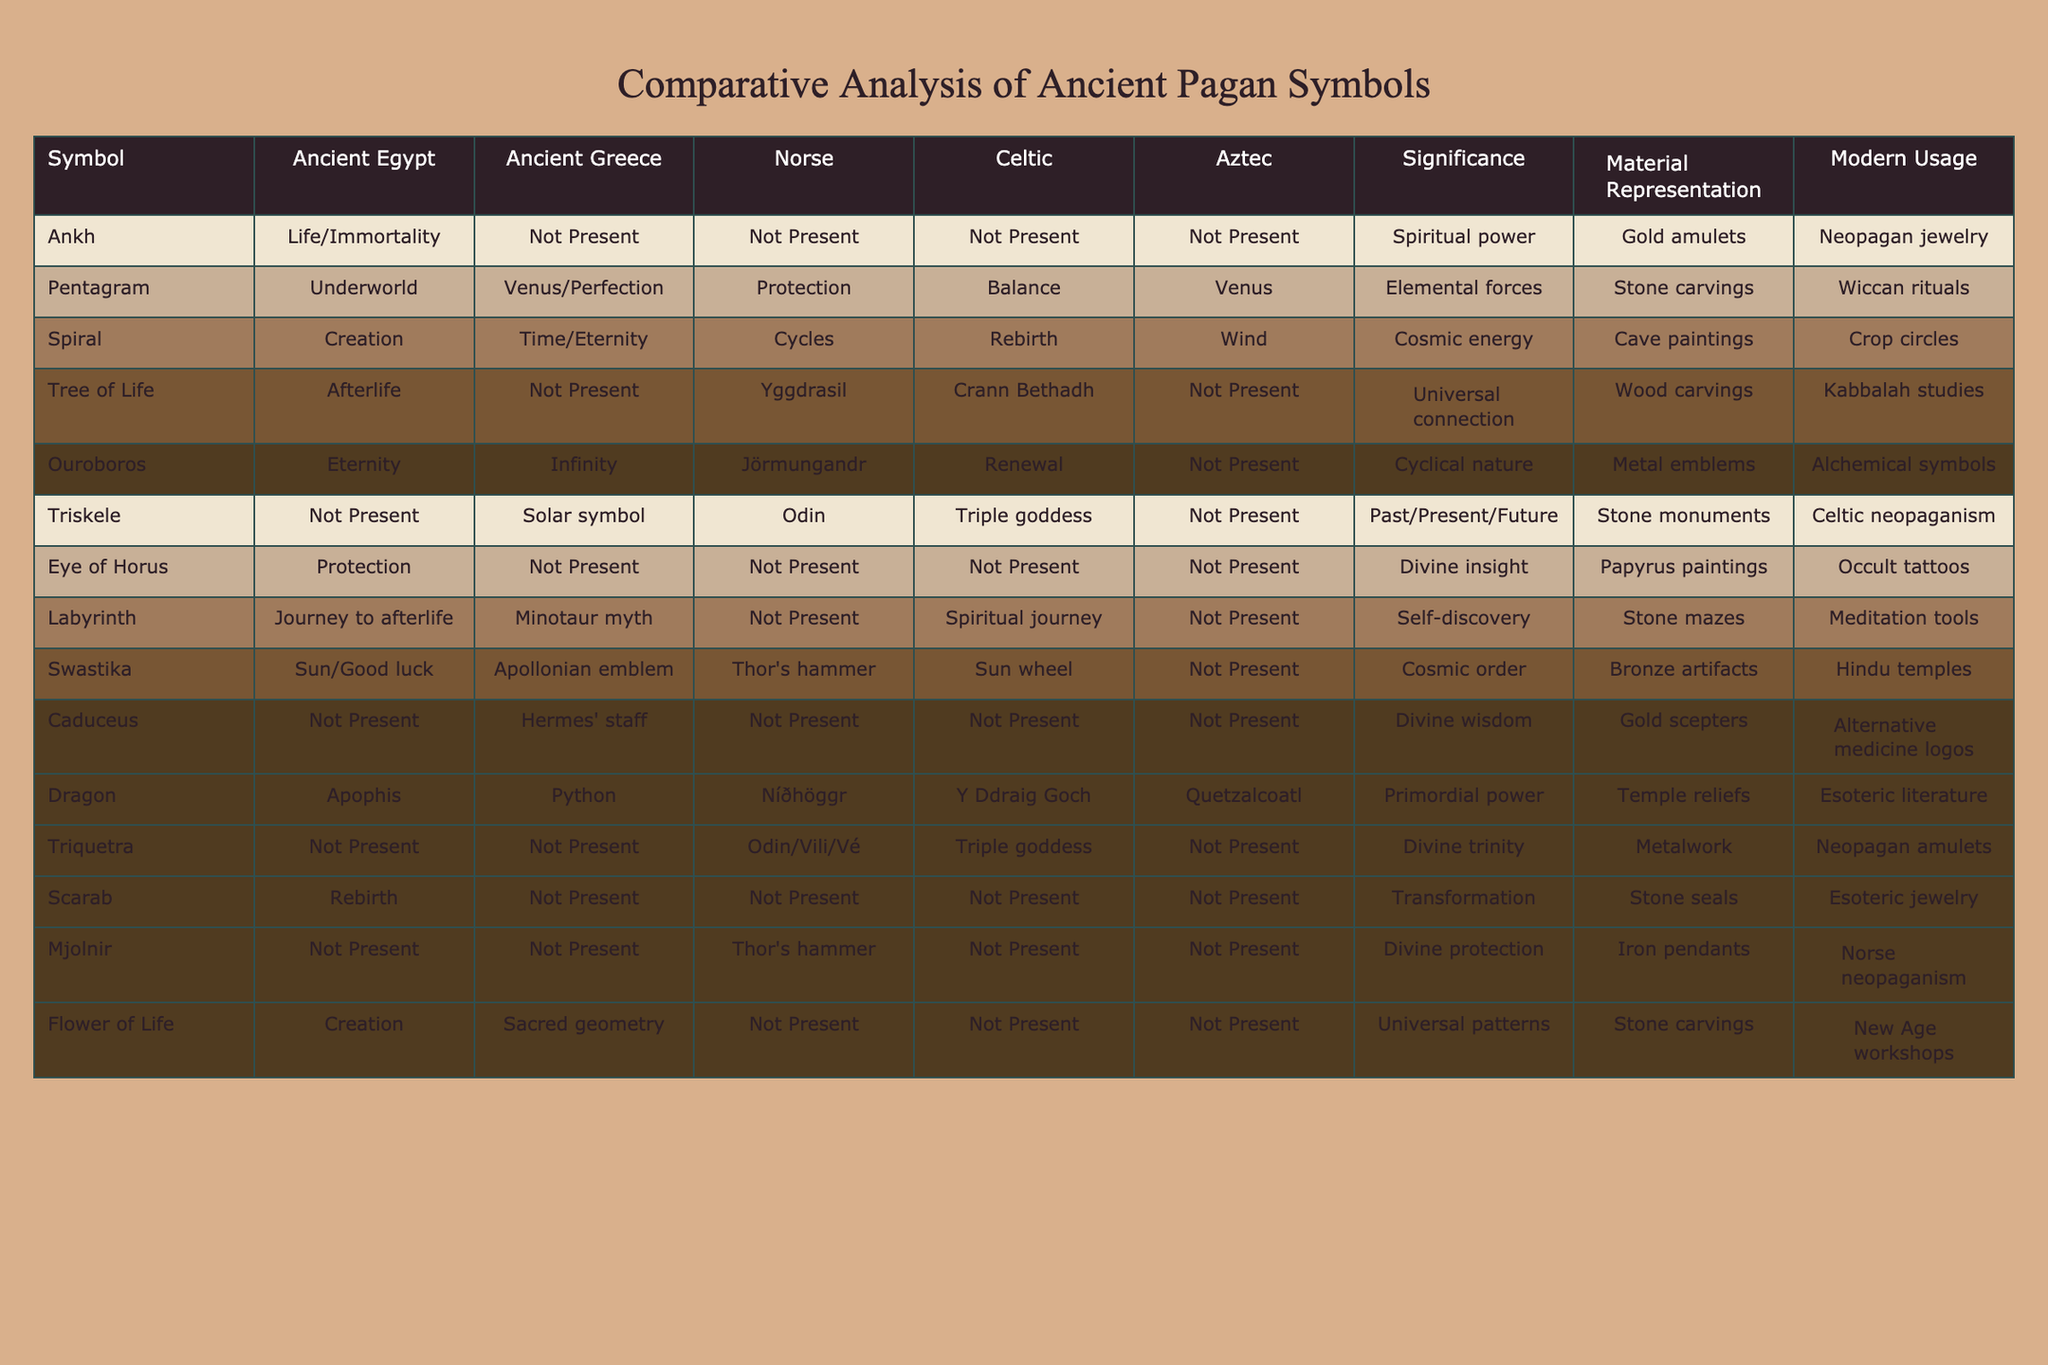What is the significance of the Ankh symbol in Ancient Egypt? According to the table, the Ankh symbol represents life and immortality in Ancient Egypt.
Answer: Life/Immortality Which symbols are associated with the concept of protection? The symbols related to protection in the table are the Pentagram in Ancient Greece and the Eye of Horus in Ancient Egypt.
Answer: Pentagram, Eye of Horus How many cultures recognize the Ouroboros symbol, and what does it signify? The Ouroboros symbol is recognized in Ancient Egypt and Norse cultures, signifying eternity in Egypt and cyclical nature in Norse mythology.
Answer: 2 cultures; Eternity, Cyclical nature Which symbol has a representation of divine wisdom? The Caduceus is the symbol representing divine wisdom, specifically associated with Hermes' staff in Ancient Greece.
Answer: Caduceus Does the Spiral symbol appear in all cultures listed? No, the Spiral symbol does not appear in Ancient Greece and Aztec cultures according to the table.
Answer: No What is the common theme among the symbols that signify creation? The Spiral and Flower of Life symbols represent creation, with Spiral associated with creation in various cultures and Flower of Life recognized in Ancient Greece.
Answer: Creation In which cultures does the Tree of Life appear, and what is its significance? The Tree of Life appears in Ancient Egypt and Norse cultures, signifying afterlife in Egypt and the Yggdrasil in Norse mythology, which connects realms.
Answer: Ancient Egypt, Norse; Universal connection How many symbols denote the concept of renewal, and what are they? There are two symbols denoting renewal: the Ouroboros and the Dragon, with Ouroboros signifying cyclical nature and the Dragon related to primordial power in various cultures.
Answer: 2 symbols; Ouroboros, Dragon Is the Triskele symbol found in more than one culture? Yes, the Triskele symbol is found in Norse and Celtic cultures, where it is associated with Odin and the Triple Goddess, respectively.
Answer: Yes Which symbol represents the cycle of life, death, and rebirth? The Spiral is the symbol that represents cycles, specifically relating it to rebirth in various cultures as documented in the table.
Answer: Spiral 